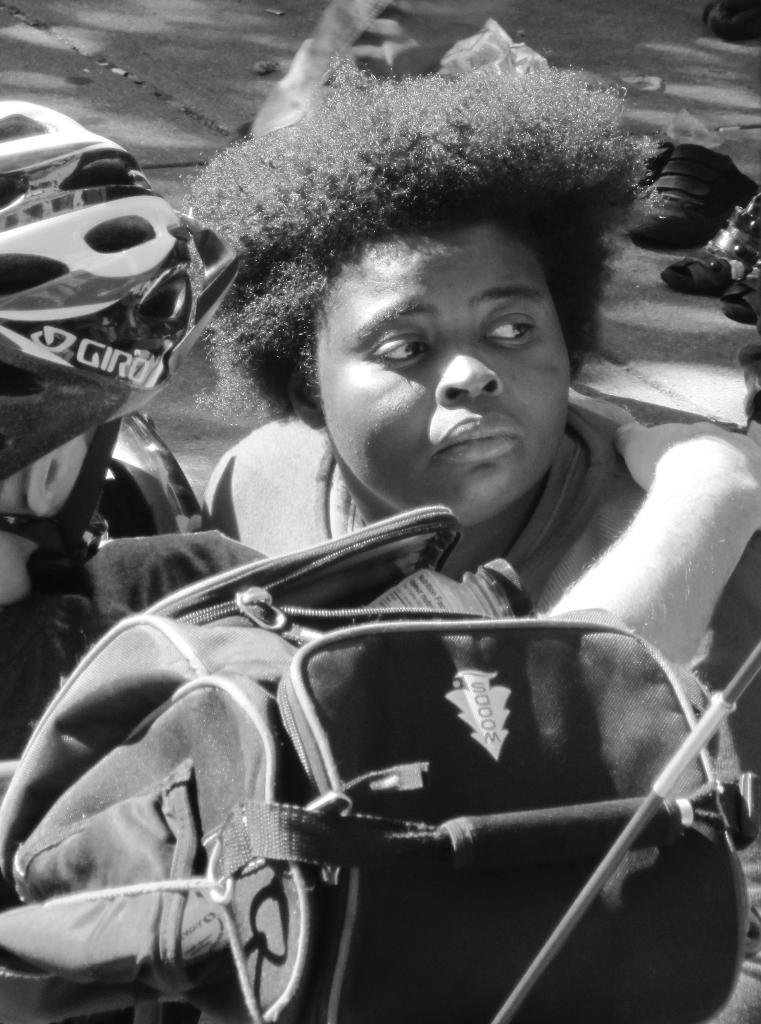What are the people in the image wearing? The persons in the image are wearing clothes. What object can be seen at the bottom of the image? There is a bag at the bottom of the image. Where is the footwear located in the image? The footwear is on the right side of the image. Can you tell me how many tickets are visible in the image? There are no tickets present in the image. What type of animals can be seen at the zoo in the image? There is no zoo or animals present in the image. 